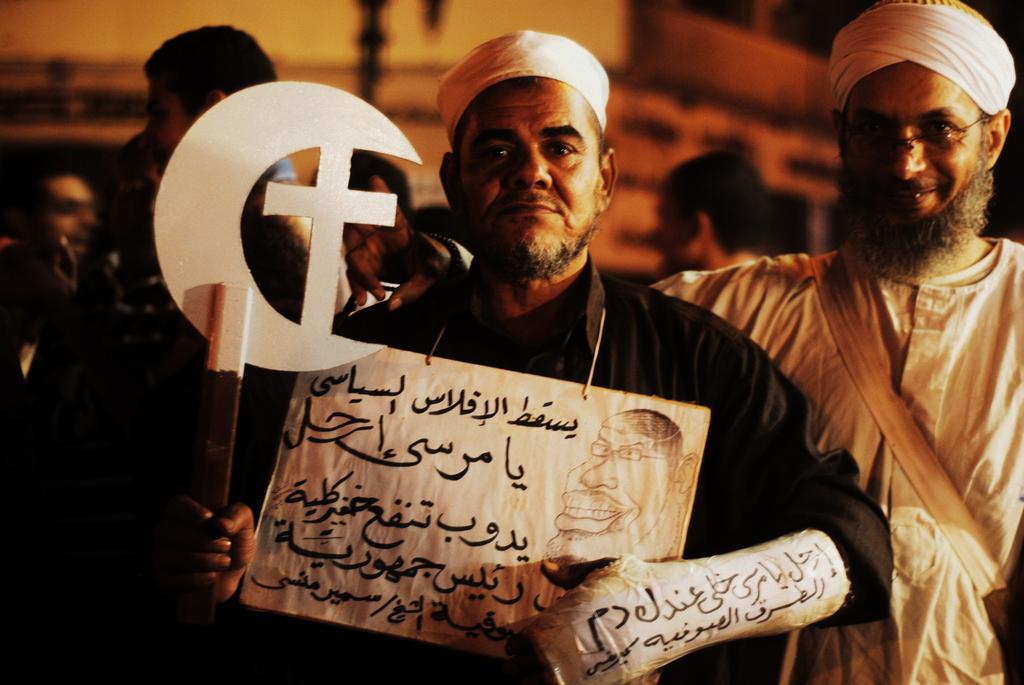Describe this image in one or two sentences. In the image few people are standing and holding something and smiling. 